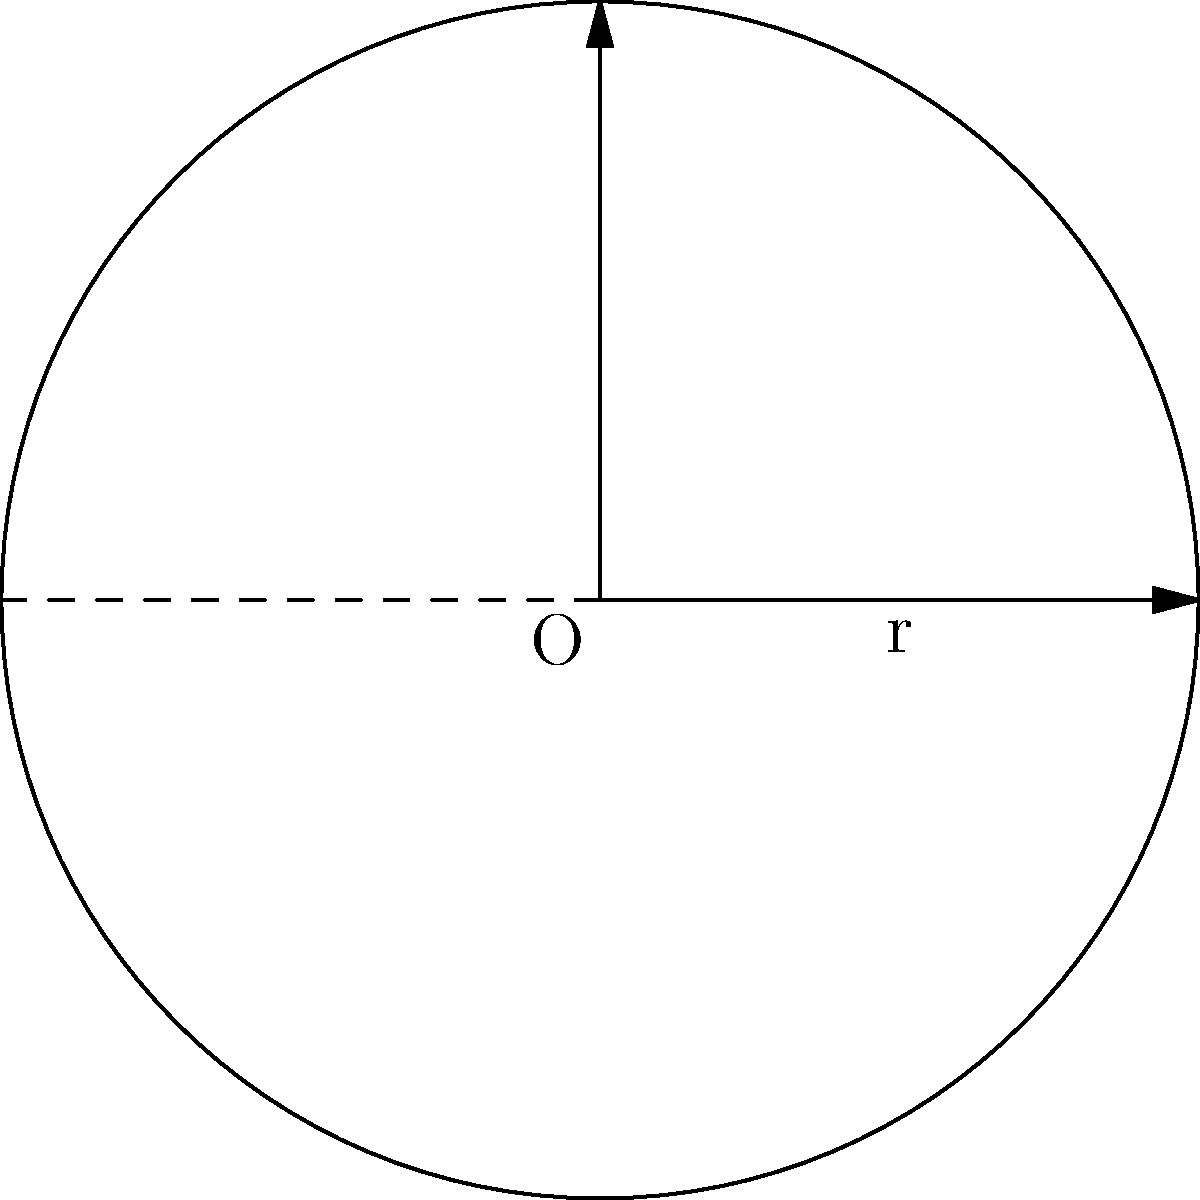A circular sundial discovered in an ancient Egyptian tomb has a radius of 1.5 meters. Calculate the area of the sundial's face, rounding your answer to two decimal places. How might the precision of this calculation have impacted the accuracy of timekeeping in ancient Egypt? To solve this problem, we'll follow these steps:

1) Recall the formula for the area of a circle: $A = \pi r^2$

2) We're given that the radius (r) is 1.5 meters.

3) Substitute this into our formula:
   $A = \pi (1.5)^2$

4) Calculate:
   $A = \pi (2.25)$
   $A \approx 3.14159 \times 2.25$
   $A \approx 7.0686 \text{ m}^2$

5) Rounding to two decimal places:
   $A \approx 7.07 \text{ m}^2$

Regarding the impact on timekeeping accuracy:

The precision of this calculation would have been crucial for accurate timekeeping in ancient Egypt. A more precise measurement and calculation of the sundial's area would have allowed for more accurate markings on the sundial face. This, in turn, would have enabled more precise time measurements throughout the day.

However, ancient Egyptians didn't have access to our modern mathematical concepts or calculating tools. They likely used approximations for π and had less precise measuring tools, which would have introduced some inaccuracy into their calculations and sundial construction. This could have led to slight discrepancies in timekeeping, especially over longer periods.

Despite these limitations, ancient Egyptian sundials were remarkably accurate for their time and played a crucial role in daily life, religious ceremonies, and astronomical observations.
Answer: $7.07 \text{ m}^2$ 